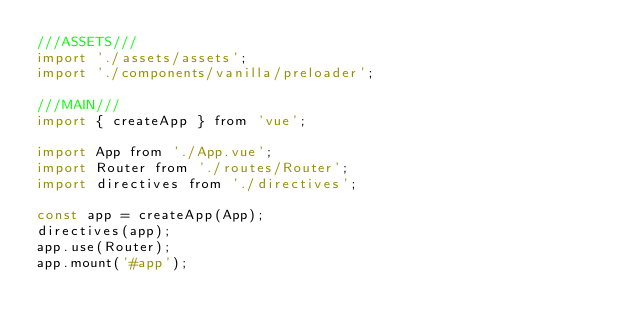Convert code to text. <code><loc_0><loc_0><loc_500><loc_500><_JavaScript_>///ASSETS///
import './assets/assets';
import './components/vanilla/preloader';

///MAIN///
import { createApp } from 'vue';

import App from './App.vue';
import Router from './routes/Router';
import directives from './directives';

const app = createApp(App);
directives(app);
app.use(Router);
app.mount('#app');
</code> 